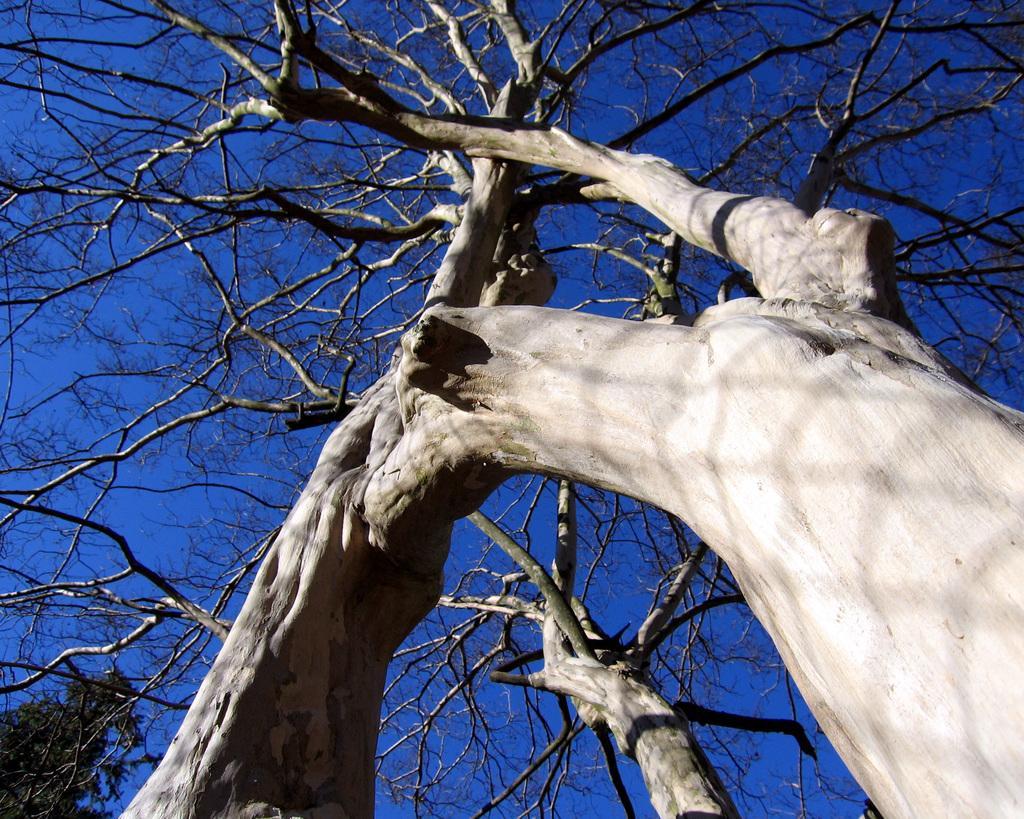Could you give a brief overview of what you see in this image? In the foreground I can see a tree and the sky. This image is taken during evening. 